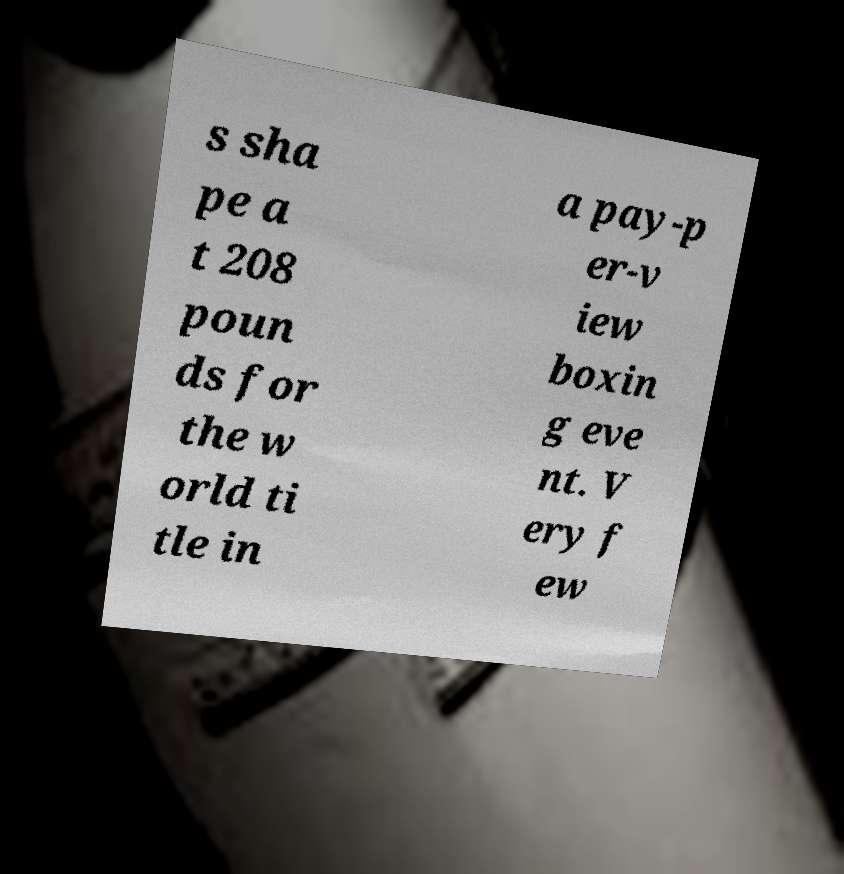What messages or text are displayed in this image? I need them in a readable, typed format. s sha pe a t 208 poun ds for the w orld ti tle in a pay-p er-v iew boxin g eve nt. V ery f ew 